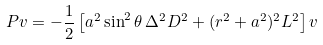Convert formula to latex. <formula><loc_0><loc_0><loc_500><loc_500>P v = - \frac { 1 } { 2 } \left [ a ^ { 2 } \sin ^ { 2 } \theta \, \Delta ^ { 2 } D ^ { 2 } + ( r ^ { 2 } + a ^ { 2 } ) ^ { 2 } L ^ { 2 } \right ] v</formula> 